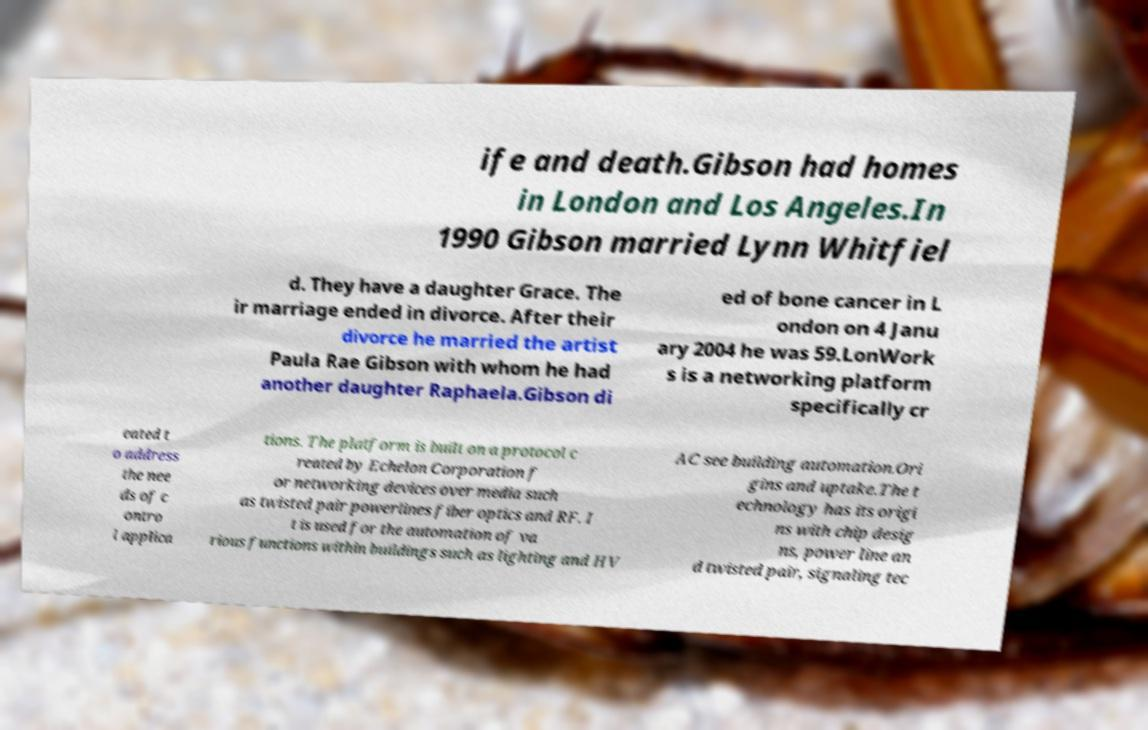What messages or text are displayed in this image? I need them in a readable, typed format. ife and death.Gibson had homes in London and Los Angeles.In 1990 Gibson married Lynn Whitfiel d. They have a daughter Grace. The ir marriage ended in divorce. After their divorce he married the artist Paula Rae Gibson with whom he had another daughter Raphaela.Gibson di ed of bone cancer in L ondon on 4 Janu ary 2004 he was 59.LonWork s is a networking platform specifically cr eated t o address the nee ds of c ontro l applica tions. The platform is built on a protocol c reated by Echelon Corporation f or networking devices over media such as twisted pair powerlines fiber optics and RF. I t is used for the automation of va rious functions within buildings such as lighting and HV AC see building automation.Ori gins and uptake.The t echnology has its origi ns with chip desig ns, power line an d twisted pair, signaling tec 